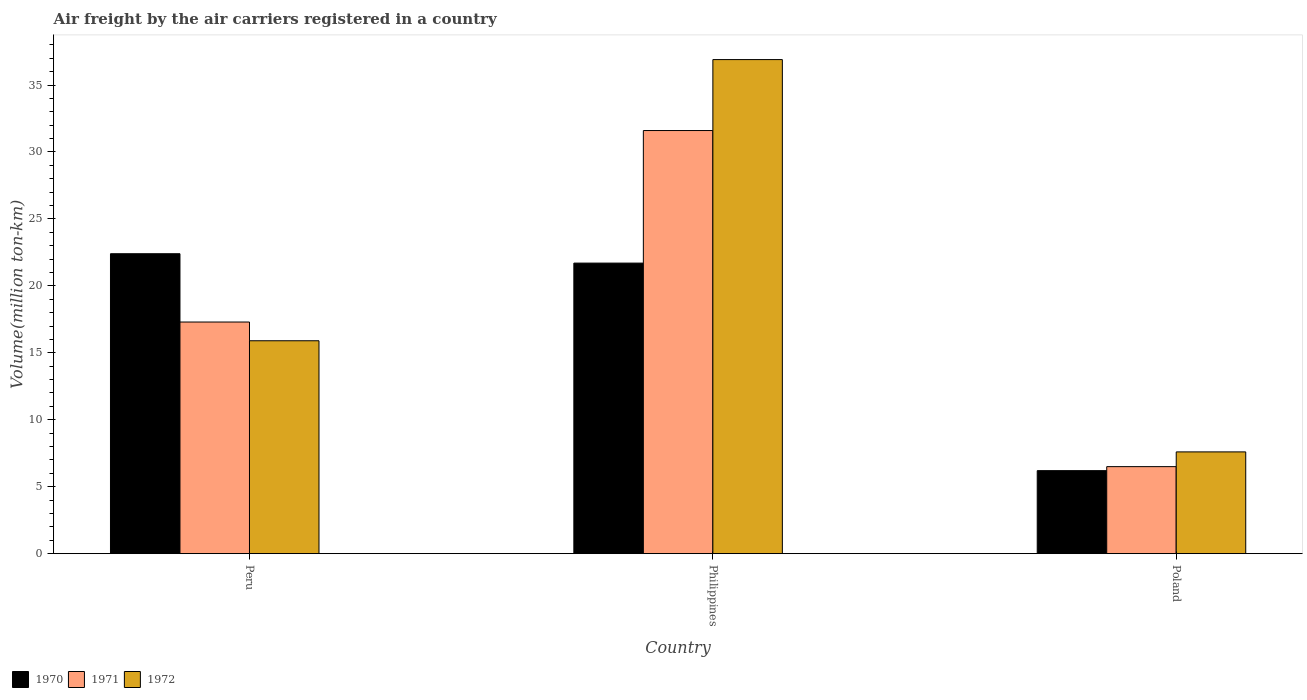How many different coloured bars are there?
Your answer should be very brief. 3. How many bars are there on the 2nd tick from the right?
Provide a short and direct response. 3. What is the volume of the air carriers in 1972 in Philippines?
Your answer should be compact. 36.9. Across all countries, what is the maximum volume of the air carriers in 1971?
Keep it short and to the point. 31.6. Across all countries, what is the minimum volume of the air carriers in 1970?
Provide a short and direct response. 6.2. In which country was the volume of the air carriers in 1970 minimum?
Keep it short and to the point. Poland. What is the total volume of the air carriers in 1970 in the graph?
Make the answer very short. 50.3. What is the difference between the volume of the air carriers in 1971 in Philippines and that in Poland?
Give a very brief answer. 25.1. What is the difference between the volume of the air carriers in 1972 in Peru and the volume of the air carriers in 1971 in Poland?
Provide a short and direct response. 9.4. What is the average volume of the air carriers in 1971 per country?
Provide a short and direct response. 18.47. What is the difference between the volume of the air carriers of/in 1970 and volume of the air carriers of/in 1972 in Peru?
Ensure brevity in your answer.  6.5. In how many countries, is the volume of the air carriers in 1971 greater than 17 million ton-km?
Your response must be concise. 2. What is the ratio of the volume of the air carriers in 1972 in Philippines to that in Poland?
Provide a succinct answer. 4.86. Is the volume of the air carriers in 1972 in Peru less than that in Philippines?
Your response must be concise. Yes. What is the difference between the highest and the second highest volume of the air carriers in 1971?
Offer a terse response. 10.8. What is the difference between the highest and the lowest volume of the air carriers in 1970?
Give a very brief answer. 16.2. Is the sum of the volume of the air carriers in 1970 in Peru and Poland greater than the maximum volume of the air carriers in 1971 across all countries?
Give a very brief answer. No. What does the 3rd bar from the right in Philippines represents?
Ensure brevity in your answer.  1970. Is it the case that in every country, the sum of the volume of the air carriers in 1970 and volume of the air carriers in 1972 is greater than the volume of the air carriers in 1971?
Your answer should be compact. Yes. Are all the bars in the graph horizontal?
Offer a very short reply. No. How many countries are there in the graph?
Keep it short and to the point. 3. What is the difference between two consecutive major ticks on the Y-axis?
Your answer should be very brief. 5. Does the graph contain any zero values?
Keep it short and to the point. No. How many legend labels are there?
Offer a terse response. 3. What is the title of the graph?
Your response must be concise. Air freight by the air carriers registered in a country. Does "1997" appear as one of the legend labels in the graph?
Provide a succinct answer. No. What is the label or title of the X-axis?
Keep it short and to the point. Country. What is the label or title of the Y-axis?
Your answer should be very brief. Volume(million ton-km). What is the Volume(million ton-km) of 1970 in Peru?
Give a very brief answer. 22.4. What is the Volume(million ton-km) of 1971 in Peru?
Offer a very short reply. 17.3. What is the Volume(million ton-km) in 1972 in Peru?
Your answer should be very brief. 15.9. What is the Volume(million ton-km) of 1970 in Philippines?
Provide a succinct answer. 21.7. What is the Volume(million ton-km) of 1971 in Philippines?
Keep it short and to the point. 31.6. What is the Volume(million ton-km) in 1972 in Philippines?
Provide a short and direct response. 36.9. What is the Volume(million ton-km) of 1970 in Poland?
Your answer should be compact. 6.2. What is the Volume(million ton-km) in 1971 in Poland?
Your answer should be very brief. 6.5. What is the Volume(million ton-km) in 1972 in Poland?
Ensure brevity in your answer.  7.6. Across all countries, what is the maximum Volume(million ton-km) in 1970?
Provide a short and direct response. 22.4. Across all countries, what is the maximum Volume(million ton-km) of 1971?
Ensure brevity in your answer.  31.6. Across all countries, what is the maximum Volume(million ton-km) of 1972?
Give a very brief answer. 36.9. Across all countries, what is the minimum Volume(million ton-km) in 1970?
Ensure brevity in your answer.  6.2. Across all countries, what is the minimum Volume(million ton-km) in 1972?
Provide a short and direct response. 7.6. What is the total Volume(million ton-km) in 1970 in the graph?
Keep it short and to the point. 50.3. What is the total Volume(million ton-km) of 1971 in the graph?
Offer a very short reply. 55.4. What is the total Volume(million ton-km) of 1972 in the graph?
Make the answer very short. 60.4. What is the difference between the Volume(million ton-km) in 1971 in Peru and that in Philippines?
Make the answer very short. -14.3. What is the difference between the Volume(million ton-km) of 1972 in Peru and that in Philippines?
Provide a short and direct response. -21. What is the difference between the Volume(million ton-km) of 1970 in Peru and that in Poland?
Provide a succinct answer. 16.2. What is the difference between the Volume(million ton-km) of 1972 in Peru and that in Poland?
Keep it short and to the point. 8.3. What is the difference between the Volume(million ton-km) in 1971 in Philippines and that in Poland?
Keep it short and to the point. 25.1. What is the difference between the Volume(million ton-km) in 1972 in Philippines and that in Poland?
Make the answer very short. 29.3. What is the difference between the Volume(million ton-km) in 1970 in Peru and the Volume(million ton-km) in 1971 in Philippines?
Offer a very short reply. -9.2. What is the difference between the Volume(million ton-km) in 1971 in Peru and the Volume(million ton-km) in 1972 in Philippines?
Provide a short and direct response. -19.6. What is the difference between the Volume(million ton-km) of 1970 in Peru and the Volume(million ton-km) of 1972 in Poland?
Ensure brevity in your answer.  14.8. What is the difference between the Volume(million ton-km) of 1971 in Peru and the Volume(million ton-km) of 1972 in Poland?
Keep it short and to the point. 9.7. What is the difference between the Volume(million ton-km) in 1970 in Philippines and the Volume(million ton-km) in 1972 in Poland?
Ensure brevity in your answer.  14.1. What is the difference between the Volume(million ton-km) in 1971 in Philippines and the Volume(million ton-km) in 1972 in Poland?
Your answer should be very brief. 24. What is the average Volume(million ton-km) in 1970 per country?
Your answer should be very brief. 16.77. What is the average Volume(million ton-km) in 1971 per country?
Your response must be concise. 18.47. What is the average Volume(million ton-km) of 1972 per country?
Ensure brevity in your answer.  20.13. What is the difference between the Volume(million ton-km) of 1971 and Volume(million ton-km) of 1972 in Peru?
Ensure brevity in your answer.  1.4. What is the difference between the Volume(million ton-km) of 1970 and Volume(million ton-km) of 1972 in Philippines?
Make the answer very short. -15.2. What is the difference between the Volume(million ton-km) in 1971 and Volume(million ton-km) in 1972 in Philippines?
Provide a succinct answer. -5.3. What is the difference between the Volume(million ton-km) of 1970 and Volume(million ton-km) of 1971 in Poland?
Provide a succinct answer. -0.3. What is the ratio of the Volume(million ton-km) in 1970 in Peru to that in Philippines?
Give a very brief answer. 1.03. What is the ratio of the Volume(million ton-km) in 1971 in Peru to that in Philippines?
Offer a terse response. 0.55. What is the ratio of the Volume(million ton-km) in 1972 in Peru to that in Philippines?
Your response must be concise. 0.43. What is the ratio of the Volume(million ton-km) of 1970 in Peru to that in Poland?
Make the answer very short. 3.61. What is the ratio of the Volume(million ton-km) in 1971 in Peru to that in Poland?
Your answer should be very brief. 2.66. What is the ratio of the Volume(million ton-km) of 1972 in Peru to that in Poland?
Give a very brief answer. 2.09. What is the ratio of the Volume(million ton-km) in 1971 in Philippines to that in Poland?
Make the answer very short. 4.86. What is the ratio of the Volume(million ton-km) in 1972 in Philippines to that in Poland?
Your response must be concise. 4.86. What is the difference between the highest and the second highest Volume(million ton-km) in 1970?
Make the answer very short. 0.7. What is the difference between the highest and the second highest Volume(million ton-km) in 1971?
Give a very brief answer. 14.3. What is the difference between the highest and the second highest Volume(million ton-km) of 1972?
Give a very brief answer. 21. What is the difference between the highest and the lowest Volume(million ton-km) in 1971?
Keep it short and to the point. 25.1. What is the difference between the highest and the lowest Volume(million ton-km) in 1972?
Your answer should be very brief. 29.3. 